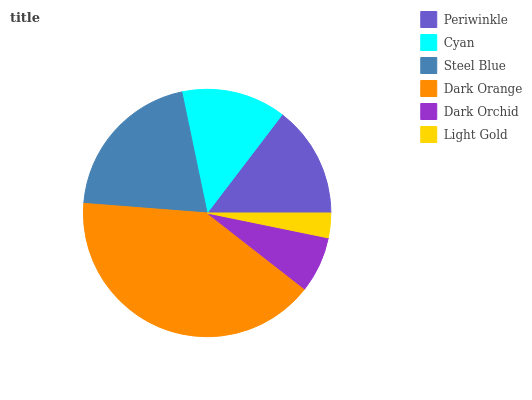Is Light Gold the minimum?
Answer yes or no. Yes. Is Dark Orange the maximum?
Answer yes or no. Yes. Is Cyan the minimum?
Answer yes or no. No. Is Cyan the maximum?
Answer yes or no. No. Is Periwinkle greater than Cyan?
Answer yes or no. Yes. Is Cyan less than Periwinkle?
Answer yes or no. Yes. Is Cyan greater than Periwinkle?
Answer yes or no. No. Is Periwinkle less than Cyan?
Answer yes or no. No. Is Periwinkle the high median?
Answer yes or no. Yes. Is Cyan the low median?
Answer yes or no. Yes. Is Light Gold the high median?
Answer yes or no. No. Is Steel Blue the low median?
Answer yes or no. No. 